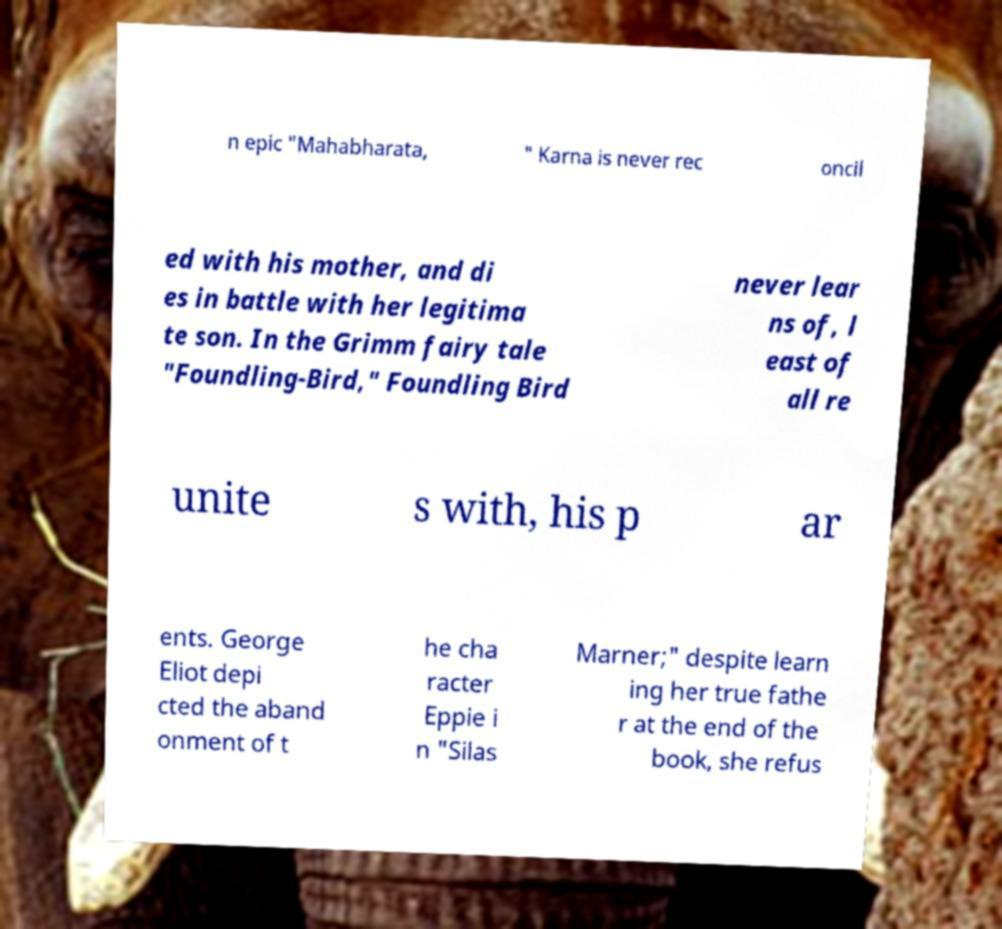Can you read and provide the text displayed in the image?This photo seems to have some interesting text. Can you extract and type it out for me? n epic "Mahabharata, " Karna is never rec oncil ed with his mother, and di es in battle with her legitima te son. In the Grimm fairy tale "Foundling-Bird," Foundling Bird never lear ns of, l east of all re unite s with, his p ar ents. George Eliot depi cted the aband onment of t he cha racter Eppie i n "Silas Marner;" despite learn ing her true fathe r at the end of the book, she refus 